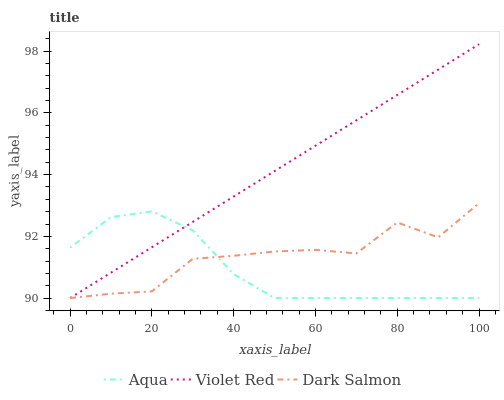Does Aqua have the minimum area under the curve?
Answer yes or no. Yes. Does Violet Red have the maximum area under the curve?
Answer yes or no. Yes. Does Dark Salmon have the minimum area under the curve?
Answer yes or no. No. Does Dark Salmon have the maximum area under the curve?
Answer yes or no. No. Is Violet Red the smoothest?
Answer yes or no. Yes. Is Dark Salmon the roughest?
Answer yes or no. Yes. Is Aqua the smoothest?
Answer yes or no. No. Is Aqua the roughest?
Answer yes or no. No. Does Violet Red have the lowest value?
Answer yes or no. Yes. Does Violet Red have the highest value?
Answer yes or no. Yes. Does Dark Salmon have the highest value?
Answer yes or no. No. Does Aqua intersect Dark Salmon?
Answer yes or no. Yes. Is Aqua less than Dark Salmon?
Answer yes or no. No. Is Aqua greater than Dark Salmon?
Answer yes or no. No. 